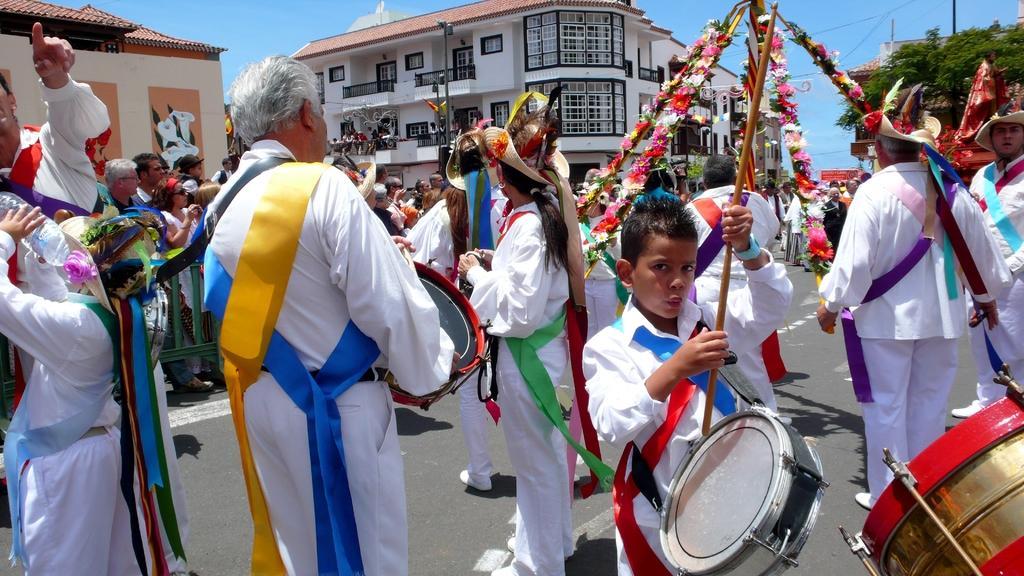Describe this image in one or two sentences. In the image we can see there are people who are standing and at the back there is a building. 